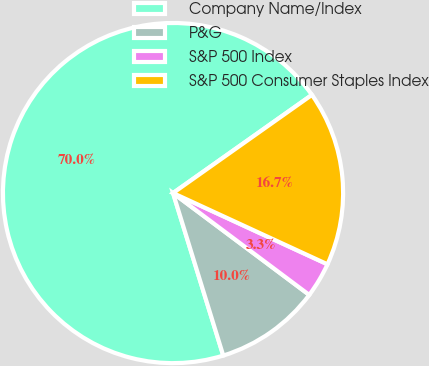<chart> <loc_0><loc_0><loc_500><loc_500><pie_chart><fcel>Company Name/Index<fcel>P&G<fcel>S&P 500 Index<fcel>S&P 500 Consumer Staples Index<nl><fcel>69.98%<fcel>10.01%<fcel>3.34%<fcel>16.67%<nl></chart> 